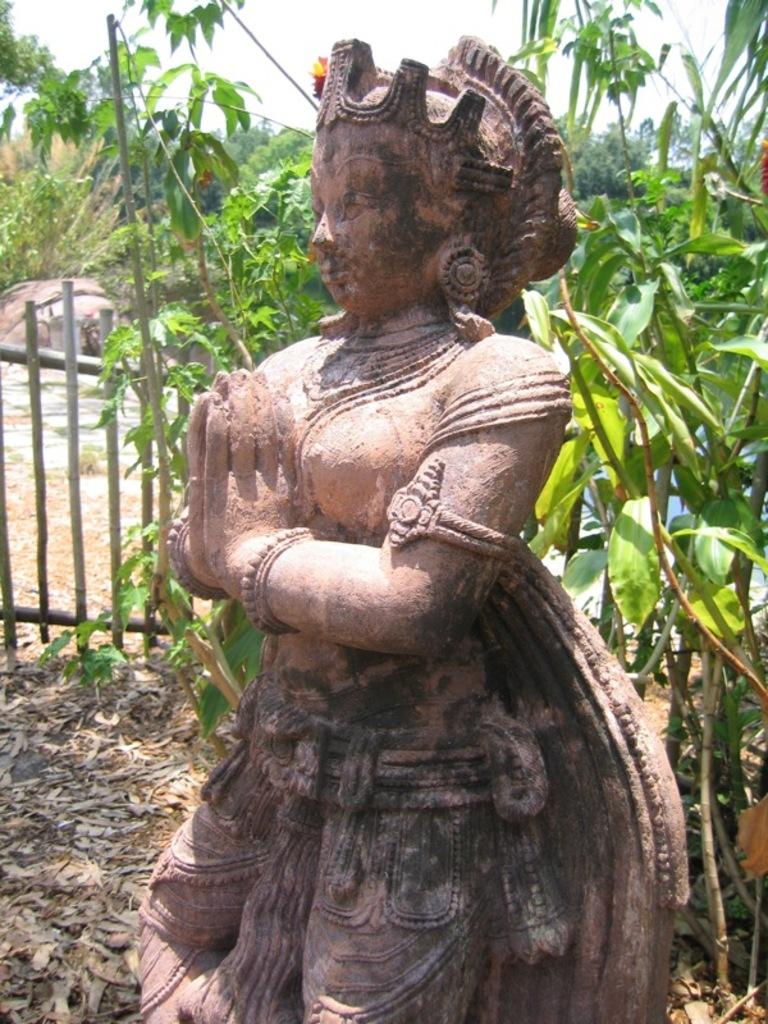What is the main subject in the image? There is a statue in the image. What can be seen behind the statue? There are plants behind the statue. What type of barrier is present in the image? There is a wooden fence in the image. What is visible in the background of the image? There are trees and the sky in the background of the image. How many friends are standing next to the statue in the image? There are no friends present in the image; it only features a statue, plants, a wooden fence, trees, and the sky. What type of pets can be seen playing with the statue in the image? There are no pets present in the image; it only features a statue, plants, a wooden fence, trees, and the sky. 